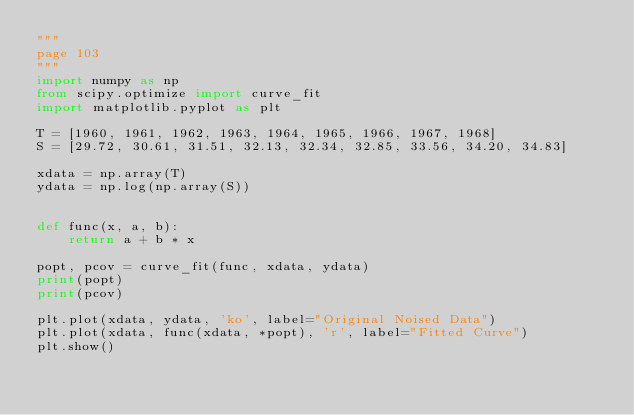<code> <loc_0><loc_0><loc_500><loc_500><_Python_>"""
page 103
"""
import numpy as np
from scipy.optimize import curve_fit
import matplotlib.pyplot as plt

T = [1960, 1961, 1962, 1963, 1964, 1965, 1966, 1967, 1968]
S = [29.72, 30.61, 31.51, 32.13, 32.34, 32.85, 33.56, 34.20, 34.83]

xdata = np.array(T)
ydata = np.log(np.array(S))


def func(x, a, b):
    return a + b * x

popt, pcov = curve_fit(func, xdata, ydata)
print(popt)
print(pcov)

plt.plot(xdata, ydata, 'ko', label="Original Noised Data")
plt.plot(xdata, func(xdata, *popt), 'r', label="Fitted Curve")
plt.show()
</code> 